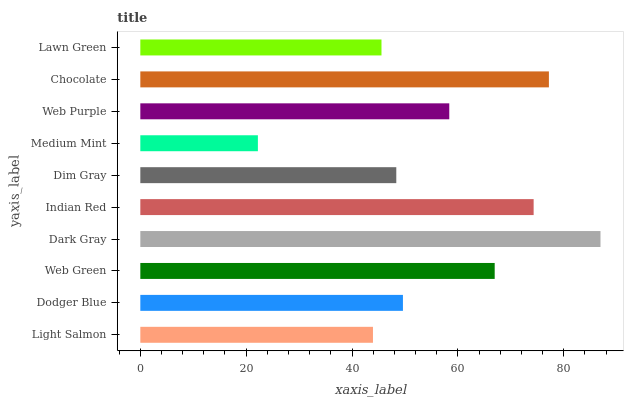Is Medium Mint the minimum?
Answer yes or no. Yes. Is Dark Gray the maximum?
Answer yes or no. Yes. Is Dodger Blue the minimum?
Answer yes or no. No. Is Dodger Blue the maximum?
Answer yes or no. No. Is Dodger Blue greater than Light Salmon?
Answer yes or no. Yes. Is Light Salmon less than Dodger Blue?
Answer yes or no. Yes. Is Light Salmon greater than Dodger Blue?
Answer yes or no. No. Is Dodger Blue less than Light Salmon?
Answer yes or no. No. Is Web Purple the high median?
Answer yes or no. Yes. Is Dodger Blue the low median?
Answer yes or no. Yes. Is Dim Gray the high median?
Answer yes or no. No. Is Medium Mint the low median?
Answer yes or no. No. 